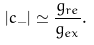<formula> <loc_0><loc_0><loc_500><loc_500>| c _ { - } | \simeq \frac { g _ { r e } } { g _ { e x } } .</formula> 